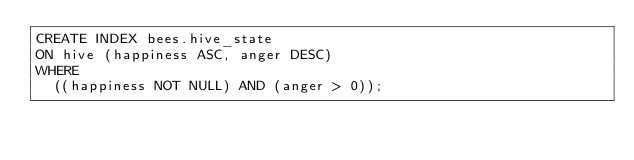<code> <loc_0><loc_0><loc_500><loc_500><_SQL_>CREATE INDEX bees.hive_state
ON hive (happiness ASC, anger DESC)
WHERE
  ((happiness NOT NULL) AND (anger > 0));
</code> 